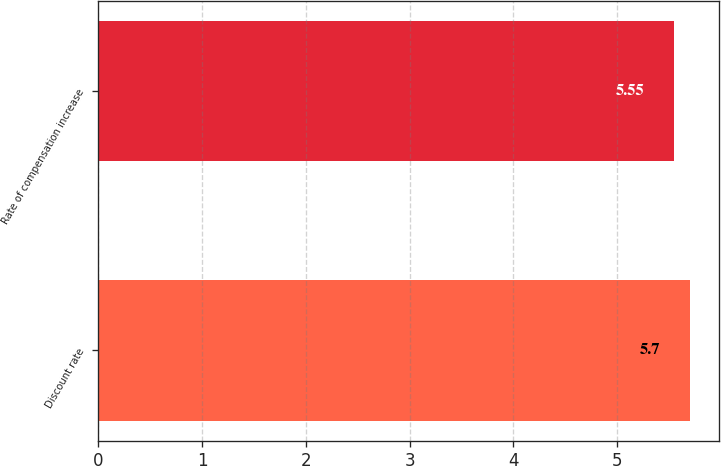Convert chart. <chart><loc_0><loc_0><loc_500><loc_500><bar_chart><fcel>Discount rate<fcel>Rate of compensation increase<nl><fcel>5.7<fcel>5.55<nl></chart> 